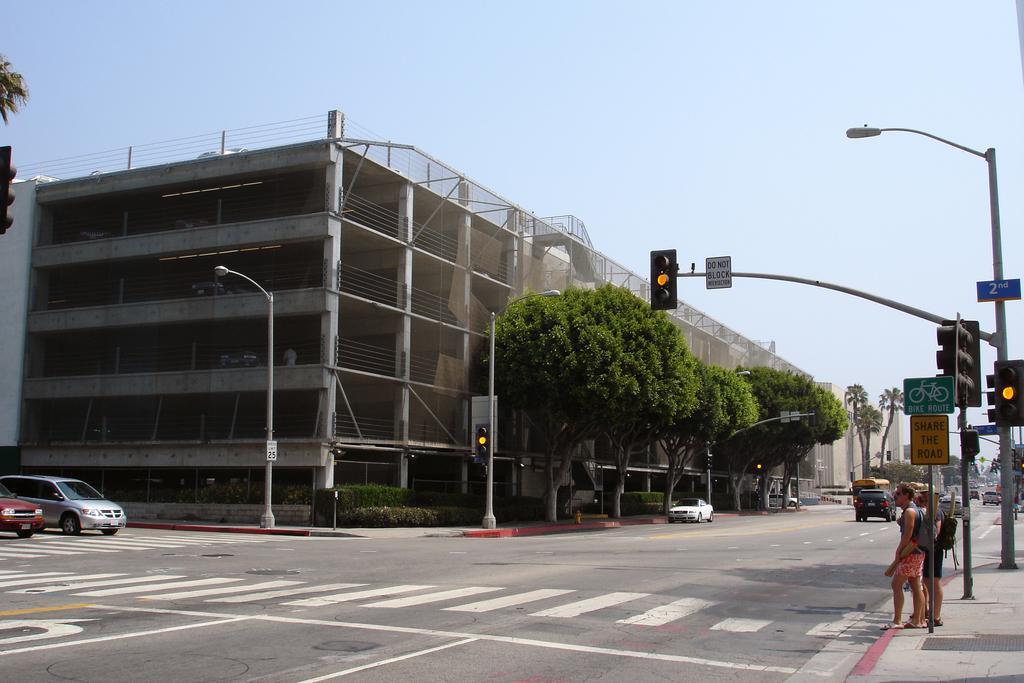Describe this image in one or two sentences. There are two vehicles on the left side of this image and there are some other cars on the road as we can see on the right side of this image. There are some trees and a building in the background. There are signal boards and some persons are standing on the right side of this image. 